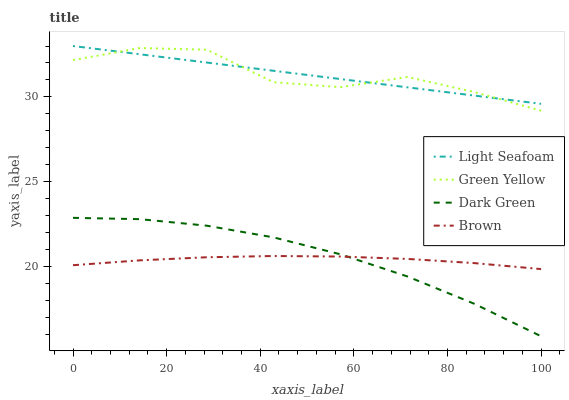Does Brown have the minimum area under the curve?
Answer yes or no. Yes. Does Green Yellow have the maximum area under the curve?
Answer yes or no. Yes. Does Light Seafoam have the minimum area under the curve?
Answer yes or no. No. Does Light Seafoam have the maximum area under the curve?
Answer yes or no. No. Is Light Seafoam the smoothest?
Answer yes or no. Yes. Is Green Yellow the roughest?
Answer yes or no. Yes. Is Green Yellow the smoothest?
Answer yes or no. No. Is Light Seafoam the roughest?
Answer yes or no. No. Does Dark Green have the lowest value?
Answer yes or no. Yes. Does Green Yellow have the lowest value?
Answer yes or no. No. Does Light Seafoam have the highest value?
Answer yes or no. Yes. Does Green Yellow have the highest value?
Answer yes or no. No. Is Dark Green less than Green Yellow?
Answer yes or no. Yes. Is Green Yellow greater than Dark Green?
Answer yes or no. Yes. Does Dark Green intersect Brown?
Answer yes or no. Yes. Is Dark Green less than Brown?
Answer yes or no. No. Is Dark Green greater than Brown?
Answer yes or no. No. Does Dark Green intersect Green Yellow?
Answer yes or no. No. 